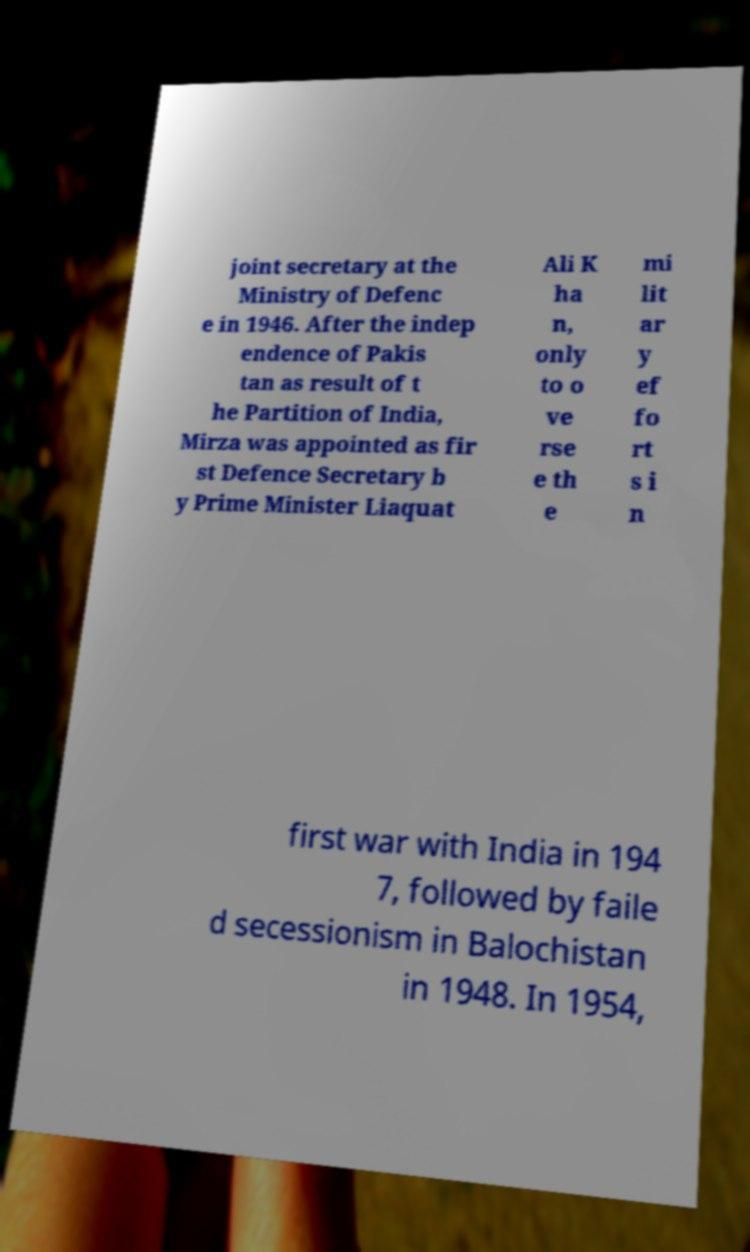Could you assist in decoding the text presented in this image and type it out clearly? joint secretary at the Ministry of Defenc e in 1946. After the indep endence of Pakis tan as result of t he Partition of India, Mirza was appointed as fir st Defence Secretary b y Prime Minister Liaquat Ali K ha n, only to o ve rse e th e mi lit ar y ef fo rt s i n first war with India in 194 7, followed by faile d secessionism in Balochistan in 1948. In 1954, 